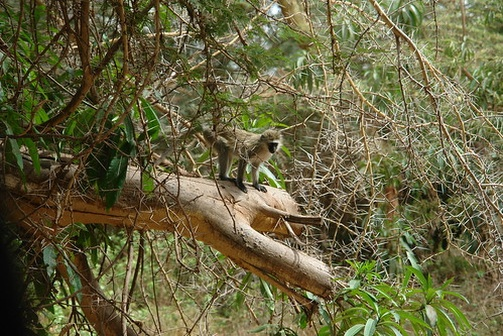If the monkey could talk, what story do you think it would tell us about its life in the forest? If the monkey could talk, it might share an adventurous tale of its life in the forest. It could describe the joy of waking up to the sounds of chirping birds and rustling leaves, the thrill of leaping between branches in search of the juiciest fruits, and the camaraderie shared with other monkeys. It could recount close encounters with predators, detailing how it evaded them with quick wit and agility. The monkey might also speak about the changing seasons, how the forest transforms with each, bringing different challenges and delights – from the abundance of the rainy season to the quieter, reflective times of the dry months. It would probably express a profound connection to its home, emphasizing the importance of every tree, branch, and leaf that makes up its world. Imagine the monkey is a character from a superhero film. How would it utilize its environment to fight villains? As a superhero, the monkey would use its incredible agility and intimate knowledge of the forest to outmaneuver and outsmart villains. Swinging deftly from branch to branch, it could launch surprise attacks from above, using the dense foliage as perfect camouflage. The monkey might have enhanced senses, detecting threats from great distances and communicating with other animals to rally an army of wild allies. It could use the natural resources around it, like sharp stones or resilient vines, to craft tools and weapons. This superhero monkey, protecting its forest home, would be quick, cunning, and always one step ahead of its adversaries, utilizing its environment for both defense and attack. 